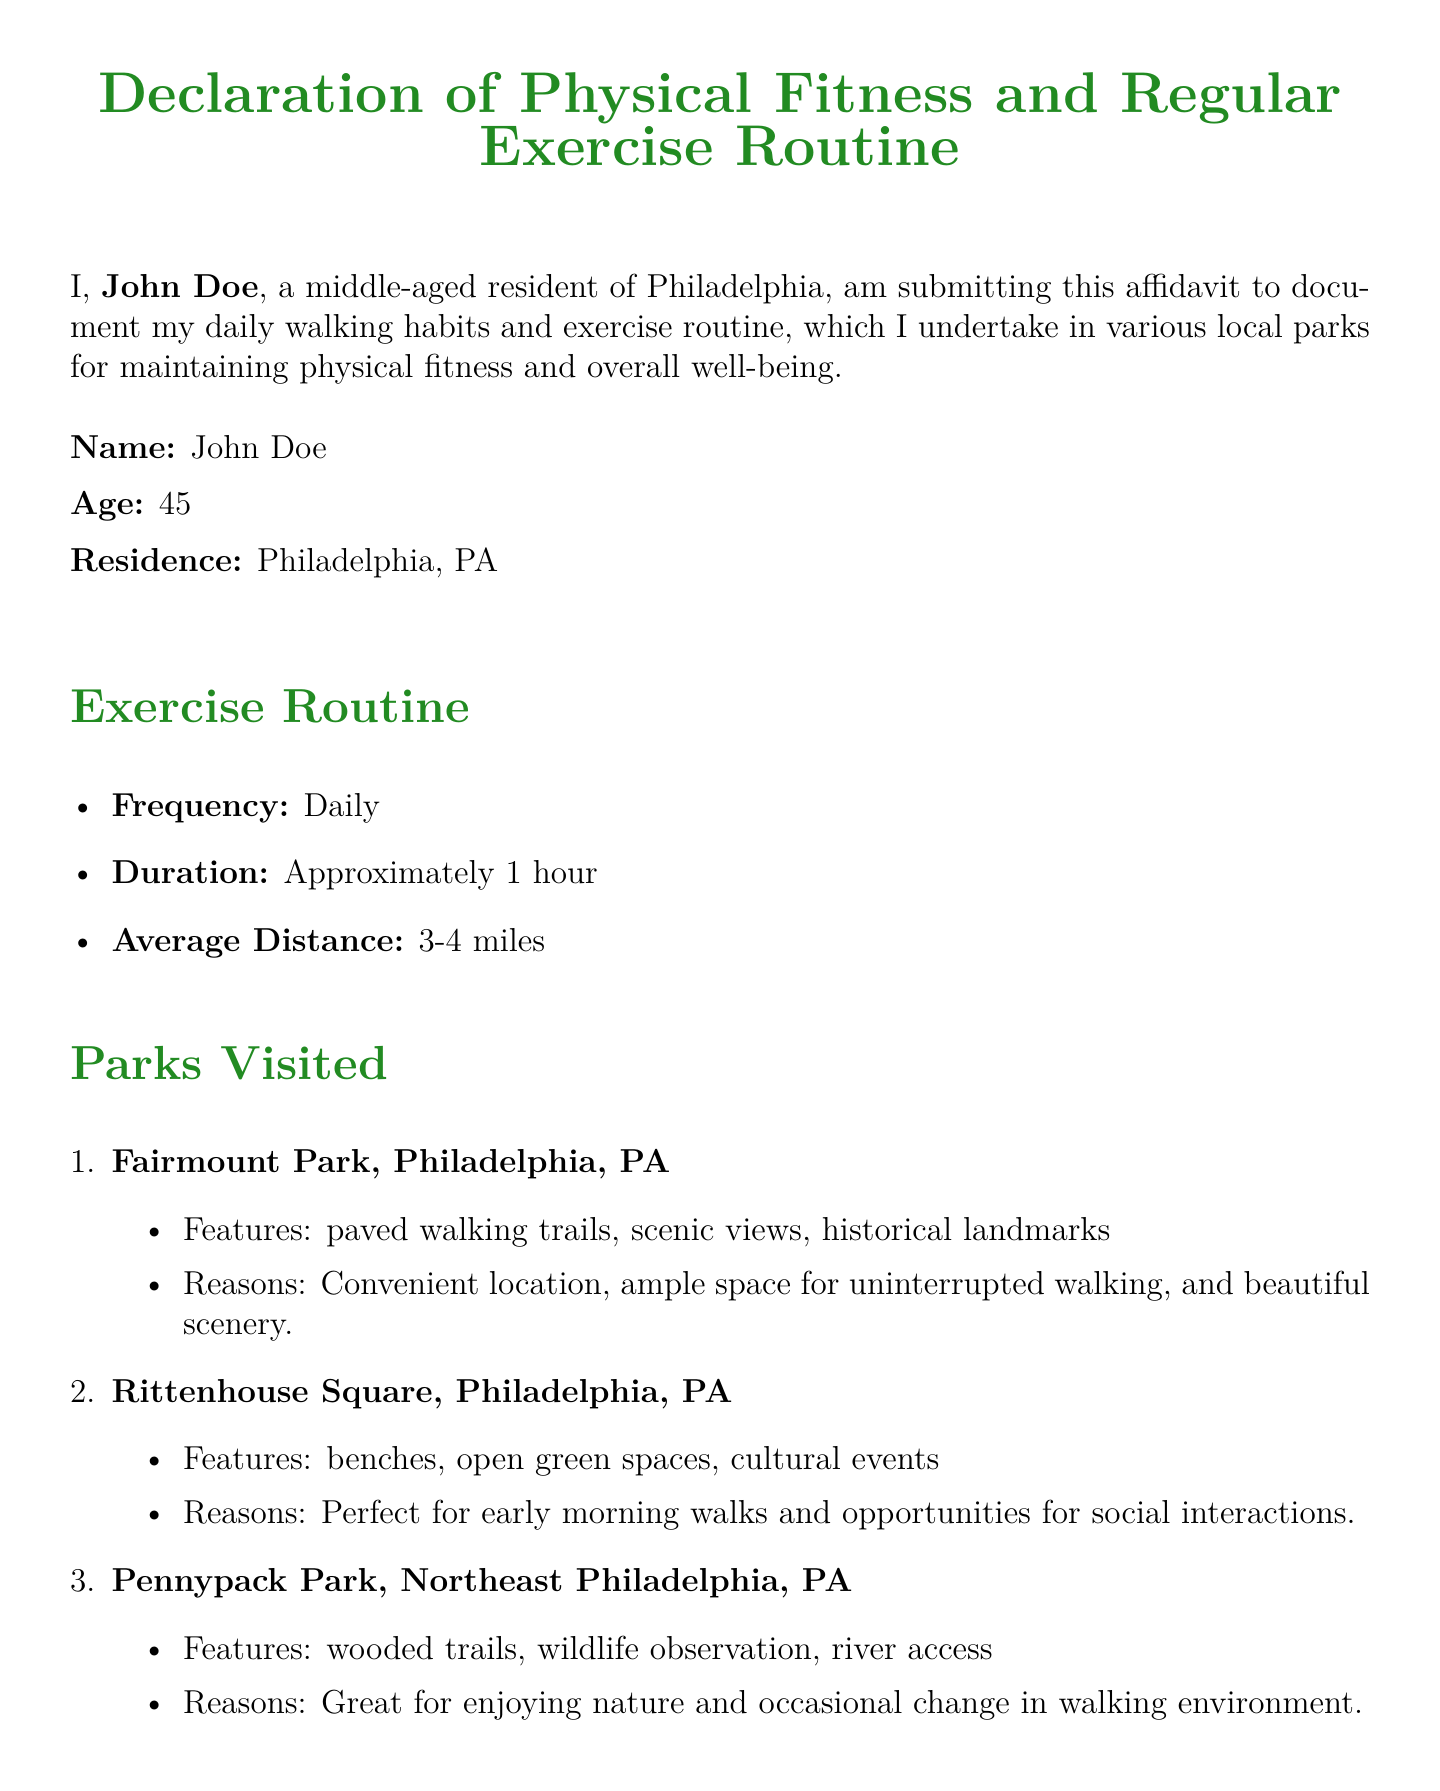What is the name of the person making the declaration? The declaration states the name of the individual making the affidavit as John Doe.
Answer: John Doe How old is John Doe? The document specifies that John Doe is 45 years old.
Answer: 45 What is the frequency of John Doe's exercise routine? The exercise routine mentions that John Doe exercises daily.
Answer: Daily What is the average distance John Doe walks? It states that John Doe walks an average distance of 3-4 miles.
Answer: 3-4 miles Which park is mentioned first in the list of parks visited? The document lists Fairmount Park as the first park visited.
Answer: Fairmount Park What is one of the benefits reported from walking? The affidavit lists various benefits, including improved cardiovascular health as one of them.
Answer: Improved cardiovascular health What date was the affidavit signed? The document specifies that the affidavit was signed on October 10, 2023.
Answer: October 10, 2023 What is the duration of John Doe's daily exercise? The declaration states that John Doe exercises for approximately 1 hour daily.
Answer: Approximately 1 hour Why does John Doe visit Rittenhouse Square? The document notes that he finds it perfect for early morning walks and social interactions.
Answer: Perfect for early morning walks and opportunities for social interactions 